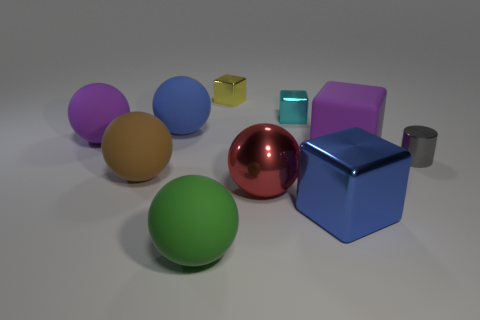There is a cyan object that is the same shape as the blue metal object; what size is it?
Offer a very short reply. Small. Is the number of tiny blue spheres less than the number of brown rubber objects?
Keep it short and to the point. Yes. Does the cylinder have the same size as the sphere that is in front of the big blue block?
Offer a very short reply. No. What number of rubber objects are either big blue objects or small cyan cubes?
Provide a short and direct response. 1. Is the number of tiny purple rubber objects greater than the number of big red metal objects?
Give a very brief answer. No. There is a object that is the same color as the rubber cube; what size is it?
Provide a short and direct response. Large. What is the shape of the purple matte object to the right of the large blue object that is in front of the cylinder?
Provide a succinct answer. Cube. There is a large cube that is in front of the tiny object right of the small cyan metallic thing; is there a large purple rubber sphere that is on the left side of it?
Ensure brevity in your answer.  Yes. What is the color of the other shiny object that is the same size as the red shiny object?
Offer a terse response. Blue. What shape is the large object that is both behind the red thing and right of the metal sphere?
Your answer should be very brief. Cube. 